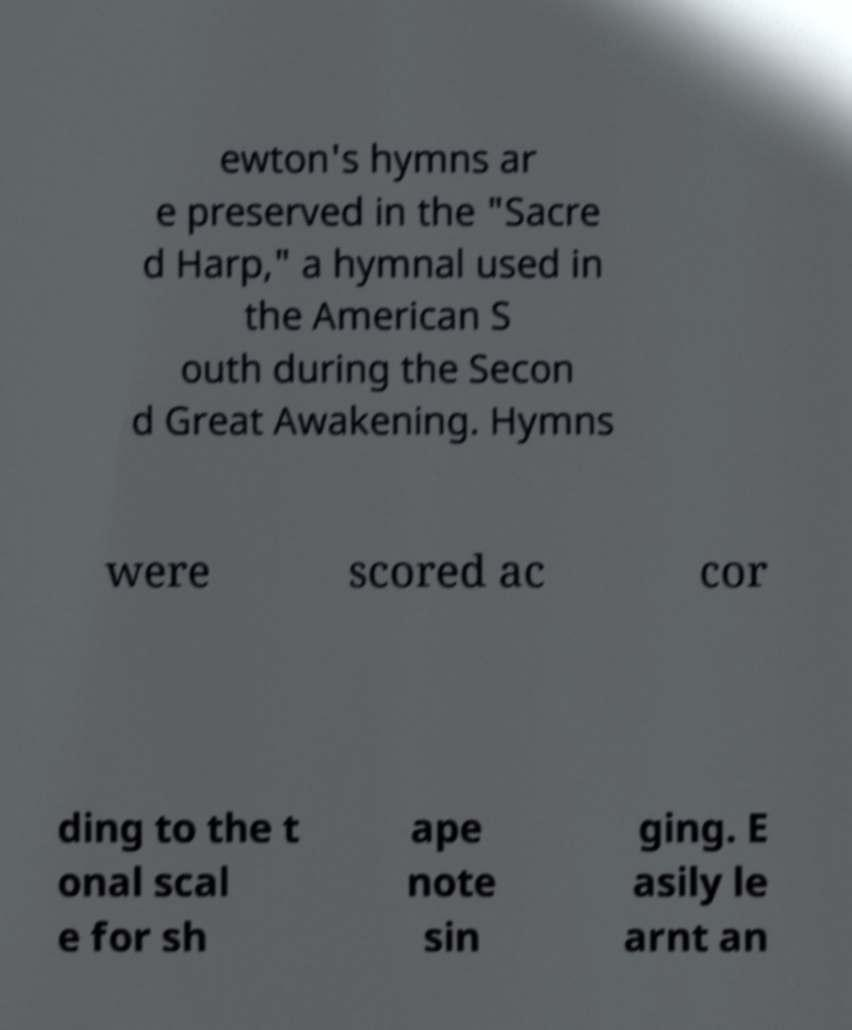Please identify and transcribe the text found in this image. ewton's hymns ar e preserved in the "Sacre d Harp," a hymnal used in the American S outh during the Secon d Great Awakening. Hymns were scored ac cor ding to the t onal scal e for sh ape note sin ging. E asily le arnt an 